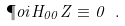Convert formula to latex. <formula><loc_0><loc_0><loc_500><loc_500>\P o i { H _ { 0 0 } } { Z } \equiv 0 \ .</formula> 